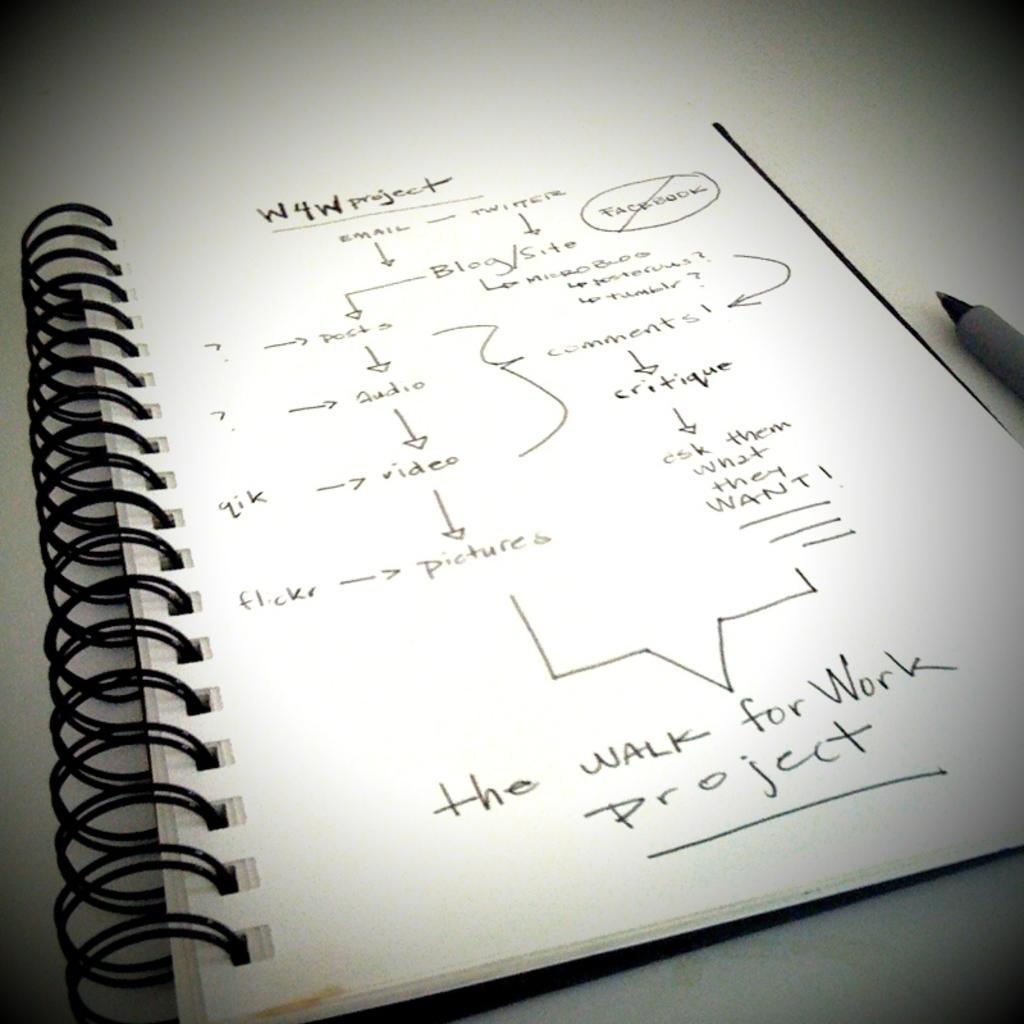Is this a flow chart?
Your answer should be very brief. Yes. What is the name of this project?
Provide a succinct answer. The walk for work project. 